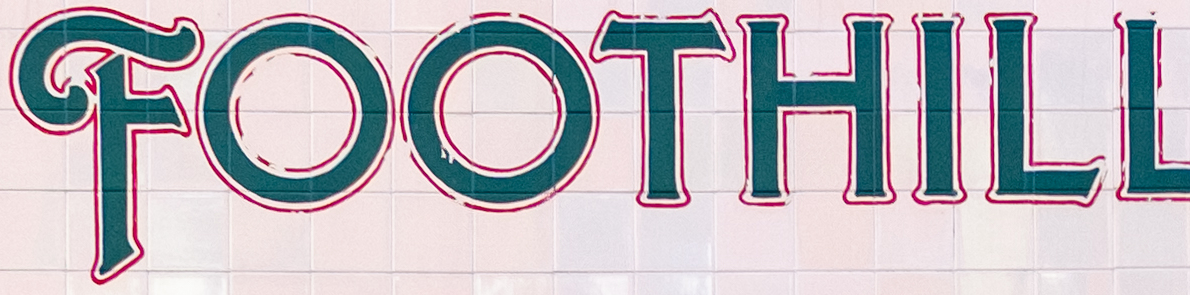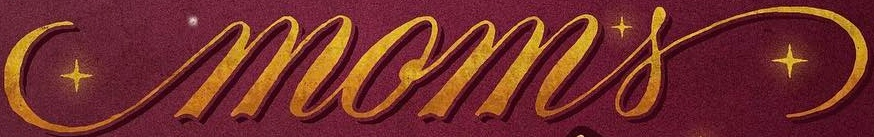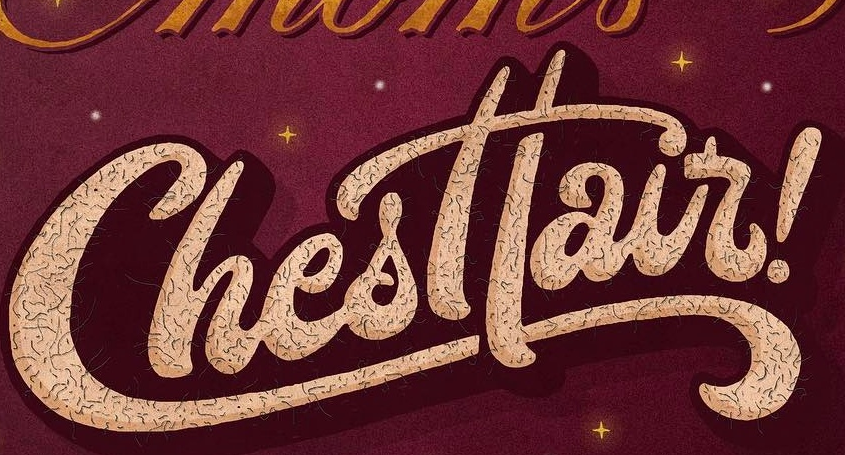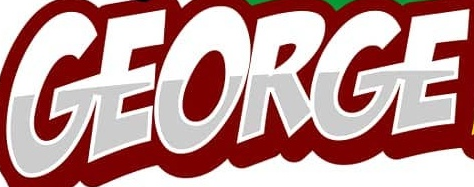What text is displayed in these images sequentially, separated by a semicolon? FOOTHILL; moms; Chesttair; GEORGE 